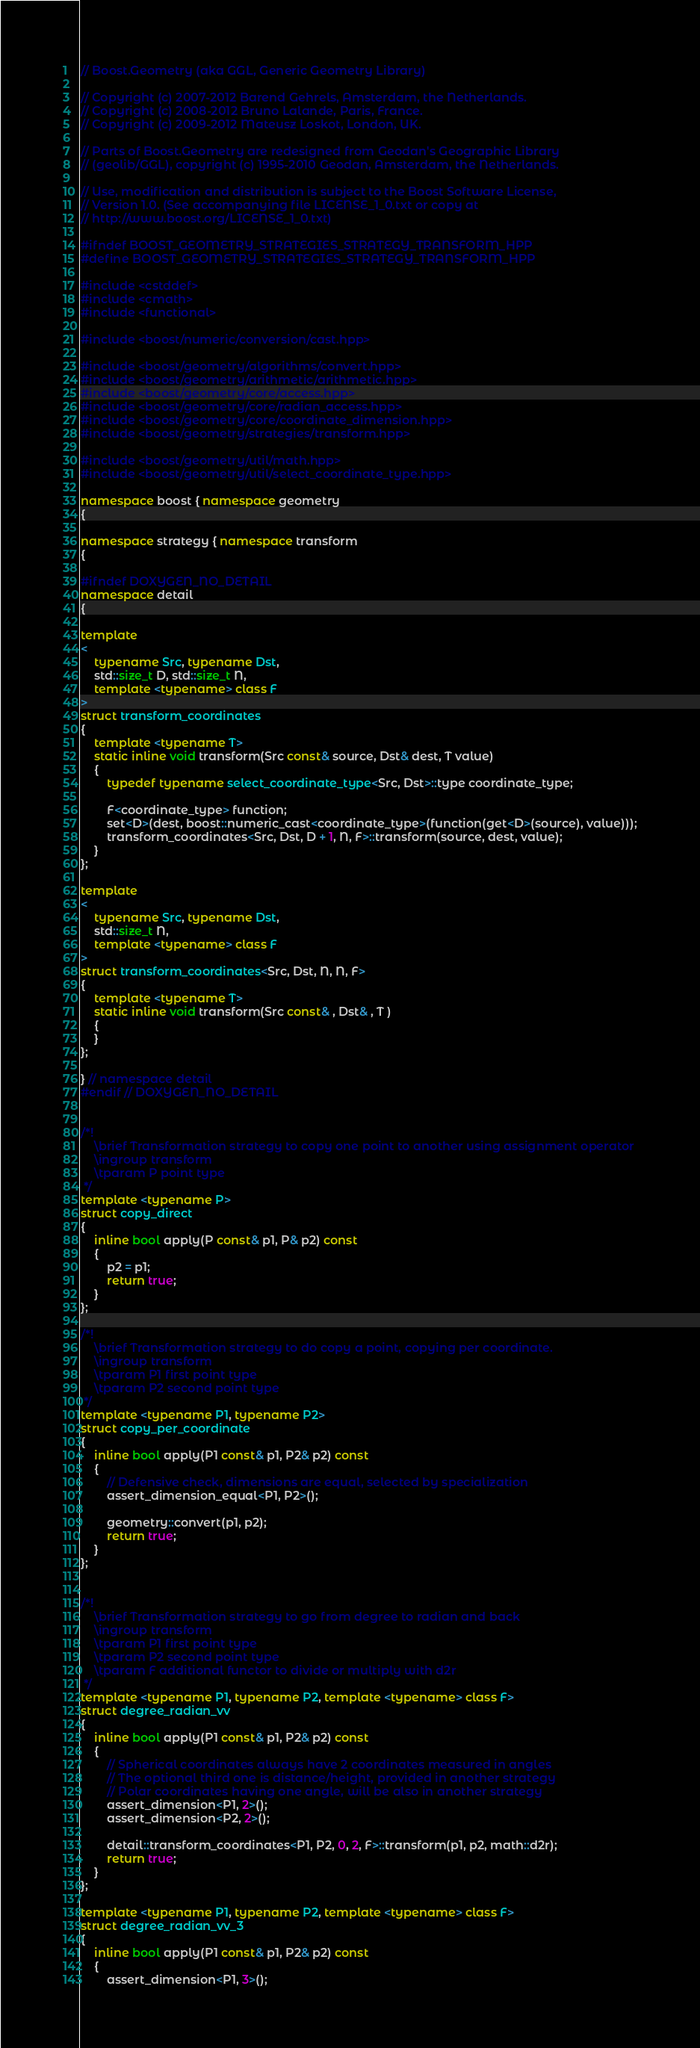<code> <loc_0><loc_0><loc_500><loc_500><_C++_>// Boost.Geometry (aka GGL, Generic Geometry Library)

// Copyright (c) 2007-2012 Barend Gehrels, Amsterdam, the Netherlands.
// Copyright (c) 2008-2012 Bruno Lalande, Paris, France.
// Copyright (c) 2009-2012 Mateusz Loskot, London, UK.

// Parts of Boost.Geometry are redesigned from Geodan's Geographic Library
// (geolib/GGL), copyright (c) 1995-2010 Geodan, Amsterdam, the Netherlands.

// Use, modification and distribution is subject to the Boost Software License,
// Version 1.0. (See accompanying file LICENSE_1_0.txt or copy at
// http://www.boost.org/LICENSE_1_0.txt)

#ifndef BOOST_GEOMETRY_STRATEGIES_STRATEGY_TRANSFORM_HPP
#define BOOST_GEOMETRY_STRATEGIES_STRATEGY_TRANSFORM_HPP

#include <cstddef>
#include <cmath>
#include <functional>

#include <boost/numeric/conversion/cast.hpp>

#include <boost/geometry/algorithms/convert.hpp>
#include <boost/geometry/arithmetic/arithmetic.hpp>
#include <boost/geometry/core/access.hpp>
#include <boost/geometry/core/radian_access.hpp>
#include <boost/geometry/core/coordinate_dimension.hpp>
#include <boost/geometry/strategies/transform.hpp>

#include <boost/geometry/util/math.hpp>
#include <boost/geometry/util/select_coordinate_type.hpp>

namespace boost { namespace geometry
{

namespace strategy { namespace transform
{

#ifndef DOXYGEN_NO_DETAIL
namespace detail
{

template
<
    typename Src, typename Dst,
    std::size_t D, std::size_t N,
    template <typename> class F
>
struct transform_coordinates
{
    template <typename T>
    static inline void transform(Src const& source, Dst& dest, T value)
    {
        typedef typename select_coordinate_type<Src, Dst>::type coordinate_type;

        F<coordinate_type> function;
        set<D>(dest, boost::numeric_cast<coordinate_type>(function(get<D>(source), value)));
        transform_coordinates<Src, Dst, D + 1, N, F>::transform(source, dest, value);
    }
};

template
<
    typename Src, typename Dst,
    std::size_t N,
    template <typename> class F
>
struct transform_coordinates<Src, Dst, N, N, F>
{
    template <typename T>
    static inline void transform(Src const& , Dst& , T )
    {
    }
};

} // namespace detail
#endif // DOXYGEN_NO_DETAIL


/*!
    \brief Transformation strategy to copy one point to another using assignment operator
    \ingroup transform
    \tparam P point type
 */
template <typename P>
struct copy_direct
{
    inline bool apply(P const& p1, P& p2) const
    {
        p2 = p1;
        return true;
    }
};

/*!
    \brief Transformation strategy to do copy a point, copying per coordinate.
    \ingroup transform
    \tparam P1 first point type
    \tparam P2 second point type
 */
template <typename P1, typename P2>
struct copy_per_coordinate
{
    inline bool apply(P1 const& p1, P2& p2) const
    {
        // Defensive check, dimensions are equal, selected by specialization
        assert_dimension_equal<P1, P2>();

        geometry::convert(p1, p2);
        return true;
    }
};


/*!
    \brief Transformation strategy to go from degree to radian and back
    \ingroup transform
    \tparam P1 first point type
    \tparam P2 second point type
    \tparam F additional functor to divide or multiply with d2r
 */
template <typename P1, typename P2, template <typename> class F>
struct degree_radian_vv
{
    inline bool apply(P1 const& p1, P2& p2) const
    {
        // Spherical coordinates always have 2 coordinates measured in angles
        // The optional third one is distance/height, provided in another strategy
        // Polar coordinates having one angle, will be also in another strategy
        assert_dimension<P1, 2>();
        assert_dimension<P2, 2>();

        detail::transform_coordinates<P1, P2, 0, 2, F>::transform(p1, p2, math::d2r);
        return true;
    }
};

template <typename P1, typename P2, template <typename> class F>
struct degree_radian_vv_3
{
    inline bool apply(P1 const& p1, P2& p2) const
    {
        assert_dimension<P1, 3>();</code> 